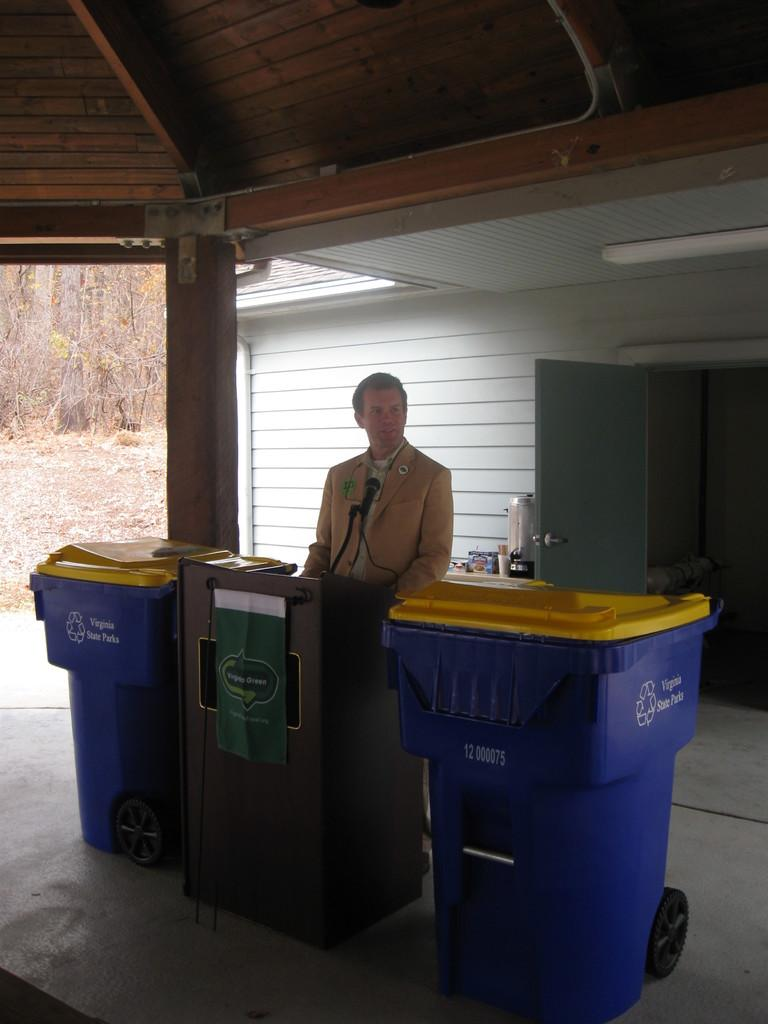Provide a one-sentence caption for the provided image. A man standing between two Virginia State Park trash cans. 